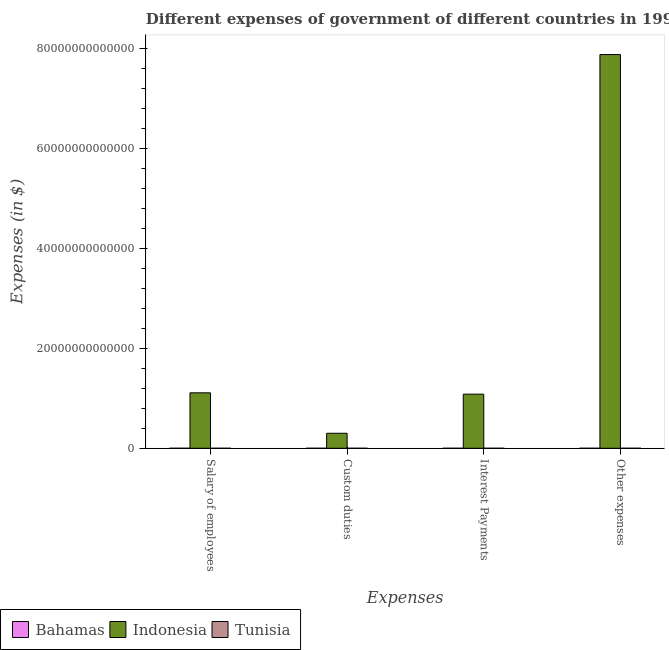How many different coloured bars are there?
Provide a succinct answer. 3. Are the number of bars per tick equal to the number of legend labels?
Keep it short and to the point. Yes. How many bars are there on the 1st tick from the left?
Ensure brevity in your answer.  3. What is the label of the 1st group of bars from the left?
Keep it short and to the point. Salary of employees. What is the amount spent on interest payments in Indonesia?
Make the answer very short. 1.08e+13. Across all countries, what is the maximum amount spent on other expenses?
Provide a short and direct response. 7.87e+13. Across all countries, what is the minimum amount spent on custom duties?
Provide a succinct answer. 3.46e+08. In which country was the amount spent on salary of employees minimum?
Your answer should be very brief. Bahamas. What is the total amount spent on salary of employees in the graph?
Make the answer very short. 1.11e+13. What is the difference between the amount spent on interest payments in Bahamas and that in Tunisia?
Give a very brief answer. -6.95e+08. What is the difference between the amount spent on custom duties in Indonesia and the amount spent on interest payments in Bahamas?
Keep it short and to the point. 3.00e+12. What is the average amount spent on other expenses per country?
Your response must be concise. 2.62e+13. What is the difference between the amount spent on interest payments and amount spent on custom duties in Indonesia?
Provide a short and direct response. 7.82e+12. In how many countries, is the amount spent on custom duties greater than 44000000000000 $?
Give a very brief answer. 0. What is the ratio of the amount spent on salary of employees in Indonesia to that in Bahamas?
Provide a succinct answer. 3.02e+04. Is the amount spent on other expenses in Bahamas less than that in Indonesia?
Ensure brevity in your answer.  Yes. Is the difference between the amount spent on salary of employees in Indonesia and Tunisia greater than the difference between the amount spent on interest payments in Indonesia and Tunisia?
Ensure brevity in your answer.  Yes. What is the difference between the highest and the second highest amount spent on salary of employees?
Provide a short and direct response. 1.11e+13. What is the difference between the highest and the lowest amount spent on other expenses?
Provide a succinct answer. 7.87e+13. Is the sum of the amount spent on custom duties in Bahamas and Tunisia greater than the maximum amount spent on other expenses across all countries?
Provide a short and direct response. No. Is it the case that in every country, the sum of the amount spent on other expenses and amount spent on salary of employees is greater than the sum of amount spent on interest payments and amount spent on custom duties?
Give a very brief answer. No. What does the 3rd bar from the left in Custom duties represents?
Your answer should be compact. Tunisia. How many bars are there?
Your answer should be very brief. 12. How many countries are there in the graph?
Ensure brevity in your answer.  3. What is the difference between two consecutive major ticks on the Y-axis?
Provide a short and direct response. 2.00e+13. Does the graph contain grids?
Give a very brief answer. No. What is the title of the graph?
Provide a succinct answer. Different expenses of government of different countries in 1997. What is the label or title of the X-axis?
Your answer should be compact. Expenses. What is the label or title of the Y-axis?
Make the answer very short. Expenses (in $). What is the Expenses (in $) of Bahamas in Salary of employees?
Make the answer very short. 3.67e+08. What is the Expenses (in $) of Indonesia in Salary of employees?
Provide a succinct answer. 1.11e+13. What is the Expenses (in $) of Tunisia in Salary of employees?
Your answer should be very brief. 2.32e+09. What is the Expenses (in $) of Bahamas in Custom duties?
Your answer should be very brief. 3.46e+08. What is the Expenses (in $) in Indonesia in Custom duties?
Your response must be concise. 3.00e+12. What is the Expenses (in $) of Tunisia in Custom duties?
Your answer should be compact. 8.49e+08. What is the Expenses (in $) in Bahamas in Interest Payments?
Give a very brief answer. 9.40e+07. What is the Expenses (in $) of Indonesia in Interest Payments?
Give a very brief answer. 1.08e+13. What is the Expenses (in $) in Tunisia in Interest Payments?
Offer a very short reply. 7.89e+08. What is the Expenses (in $) of Bahamas in Other expenses?
Provide a succinct answer. 7.12e+08. What is the Expenses (in $) of Indonesia in Other expenses?
Give a very brief answer. 7.87e+13. What is the Expenses (in $) of Tunisia in Other expenses?
Ensure brevity in your answer.  5.76e+09. Across all Expenses, what is the maximum Expenses (in $) of Bahamas?
Offer a terse response. 7.12e+08. Across all Expenses, what is the maximum Expenses (in $) of Indonesia?
Your response must be concise. 7.87e+13. Across all Expenses, what is the maximum Expenses (in $) in Tunisia?
Provide a short and direct response. 5.76e+09. Across all Expenses, what is the minimum Expenses (in $) of Bahamas?
Your answer should be compact. 9.40e+07. Across all Expenses, what is the minimum Expenses (in $) of Indonesia?
Your answer should be very brief. 3.00e+12. Across all Expenses, what is the minimum Expenses (in $) of Tunisia?
Provide a short and direct response. 7.89e+08. What is the total Expenses (in $) in Bahamas in the graph?
Your answer should be very brief. 1.52e+09. What is the total Expenses (in $) of Indonesia in the graph?
Your response must be concise. 1.04e+14. What is the total Expenses (in $) in Tunisia in the graph?
Provide a short and direct response. 9.72e+09. What is the difference between the Expenses (in $) in Bahamas in Salary of employees and that in Custom duties?
Your answer should be very brief. 2.14e+07. What is the difference between the Expenses (in $) of Indonesia in Salary of employees and that in Custom duties?
Provide a short and direct response. 8.09e+12. What is the difference between the Expenses (in $) of Tunisia in Salary of employees and that in Custom duties?
Give a very brief answer. 1.47e+09. What is the difference between the Expenses (in $) of Bahamas in Salary of employees and that in Interest Payments?
Provide a succinct answer. 2.73e+08. What is the difference between the Expenses (in $) of Indonesia in Salary of employees and that in Interest Payments?
Provide a short and direct response. 2.68e+11. What is the difference between the Expenses (in $) of Tunisia in Salary of employees and that in Interest Payments?
Ensure brevity in your answer.  1.53e+09. What is the difference between the Expenses (in $) in Bahamas in Salary of employees and that in Other expenses?
Provide a succinct answer. -3.45e+08. What is the difference between the Expenses (in $) of Indonesia in Salary of employees and that in Other expenses?
Give a very brief answer. -6.76e+13. What is the difference between the Expenses (in $) of Tunisia in Salary of employees and that in Other expenses?
Ensure brevity in your answer.  -3.44e+09. What is the difference between the Expenses (in $) in Bahamas in Custom duties and that in Interest Payments?
Your response must be concise. 2.52e+08. What is the difference between the Expenses (in $) of Indonesia in Custom duties and that in Interest Payments?
Keep it short and to the point. -7.82e+12. What is the difference between the Expenses (in $) in Tunisia in Custom duties and that in Interest Payments?
Your answer should be very brief. 5.99e+07. What is the difference between the Expenses (in $) in Bahamas in Custom duties and that in Other expenses?
Make the answer very short. -3.66e+08. What is the difference between the Expenses (in $) in Indonesia in Custom duties and that in Other expenses?
Your answer should be very brief. -7.57e+13. What is the difference between the Expenses (in $) in Tunisia in Custom duties and that in Other expenses?
Your answer should be very brief. -4.92e+09. What is the difference between the Expenses (in $) in Bahamas in Interest Payments and that in Other expenses?
Keep it short and to the point. -6.18e+08. What is the difference between the Expenses (in $) in Indonesia in Interest Payments and that in Other expenses?
Provide a short and direct response. -6.79e+13. What is the difference between the Expenses (in $) of Tunisia in Interest Payments and that in Other expenses?
Keep it short and to the point. -4.98e+09. What is the difference between the Expenses (in $) in Bahamas in Salary of employees and the Expenses (in $) in Indonesia in Custom duties?
Provide a succinct answer. -3.00e+12. What is the difference between the Expenses (in $) of Bahamas in Salary of employees and the Expenses (in $) of Tunisia in Custom duties?
Your answer should be very brief. -4.82e+08. What is the difference between the Expenses (in $) in Indonesia in Salary of employees and the Expenses (in $) in Tunisia in Custom duties?
Make the answer very short. 1.11e+13. What is the difference between the Expenses (in $) in Bahamas in Salary of employees and the Expenses (in $) in Indonesia in Interest Payments?
Provide a short and direct response. -1.08e+13. What is the difference between the Expenses (in $) in Bahamas in Salary of employees and the Expenses (in $) in Tunisia in Interest Payments?
Offer a very short reply. -4.22e+08. What is the difference between the Expenses (in $) in Indonesia in Salary of employees and the Expenses (in $) in Tunisia in Interest Payments?
Keep it short and to the point. 1.11e+13. What is the difference between the Expenses (in $) in Bahamas in Salary of employees and the Expenses (in $) in Indonesia in Other expenses?
Your response must be concise. -7.87e+13. What is the difference between the Expenses (in $) of Bahamas in Salary of employees and the Expenses (in $) of Tunisia in Other expenses?
Provide a succinct answer. -5.40e+09. What is the difference between the Expenses (in $) of Indonesia in Salary of employees and the Expenses (in $) of Tunisia in Other expenses?
Provide a succinct answer. 1.11e+13. What is the difference between the Expenses (in $) in Bahamas in Custom duties and the Expenses (in $) in Indonesia in Interest Payments?
Your response must be concise. -1.08e+13. What is the difference between the Expenses (in $) in Bahamas in Custom duties and the Expenses (in $) in Tunisia in Interest Payments?
Provide a short and direct response. -4.43e+08. What is the difference between the Expenses (in $) of Indonesia in Custom duties and the Expenses (in $) of Tunisia in Interest Payments?
Your answer should be very brief. 3.00e+12. What is the difference between the Expenses (in $) of Bahamas in Custom duties and the Expenses (in $) of Indonesia in Other expenses?
Offer a very short reply. -7.87e+13. What is the difference between the Expenses (in $) in Bahamas in Custom duties and the Expenses (in $) in Tunisia in Other expenses?
Provide a short and direct response. -5.42e+09. What is the difference between the Expenses (in $) in Indonesia in Custom duties and the Expenses (in $) in Tunisia in Other expenses?
Your answer should be compact. 2.99e+12. What is the difference between the Expenses (in $) in Bahamas in Interest Payments and the Expenses (in $) in Indonesia in Other expenses?
Offer a terse response. -7.87e+13. What is the difference between the Expenses (in $) in Bahamas in Interest Payments and the Expenses (in $) in Tunisia in Other expenses?
Your answer should be compact. -5.67e+09. What is the difference between the Expenses (in $) of Indonesia in Interest Payments and the Expenses (in $) of Tunisia in Other expenses?
Ensure brevity in your answer.  1.08e+13. What is the average Expenses (in $) of Bahamas per Expenses?
Keep it short and to the point. 3.80e+08. What is the average Expenses (in $) of Indonesia per Expenses?
Ensure brevity in your answer.  2.59e+13. What is the average Expenses (in $) of Tunisia per Expenses?
Ensure brevity in your answer.  2.43e+09. What is the difference between the Expenses (in $) in Bahamas and Expenses (in $) in Indonesia in Salary of employees?
Give a very brief answer. -1.11e+13. What is the difference between the Expenses (in $) of Bahamas and Expenses (in $) of Tunisia in Salary of employees?
Your answer should be compact. -1.95e+09. What is the difference between the Expenses (in $) of Indonesia and Expenses (in $) of Tunisia in Salary of employees?
Provide a short and direct response. 1.11e+13. What is the difference between the Expenses (in $) of Bahamas and Expenses (in $) of Indonesia in Custom duties?
Make the answer very short. -3.00e+12. What is the difference between the Expenses (in $) in Bahamas and Expenses (in $) in Tunisia in Custom duties?
Your answer should be very brief. -5.03e+08. What is the difference between the Expenses (in $) in Indonesia and Expenses (in $) in Tunisia in Custom duties?
Give a very brief answer. 3.00e+12. What is the difference between the Expenses (in $) of Bahamas and Expenses (in $) of Indonesia in Interest Payments?
Make the answer very short. -1.08e+13. What is the difference between the Expenses (in $) of Bahamas and Expenses (in $) of Tunisia in Interest Payments?
Keep it short and to the point. -6.95e+08. What is the difference between the Expenses (in $) in Indonesia and Expenses (in $) in Tunisia in Interest Payments?
Provide a short and direct response. 1.08e+13. What is the difference between the Expenses (in $) in Bahamas and Expenses (in $) in Indonesia in Other expenses?
Make the answer very short. -7.87e+13. What is the difference between the Expenses (in $) in Bahamas and Expenses (in $) in Tunisia in Other expenses?
Your response must be concise. -5.05e+09. What is the difference between the Expenses (in $) in Indonesia and Expenses (in $) in Tunisia in Other expenses?
Your answer should be very brief. 7.87e+13. What is the ratio of the Expenses (in $) in Bahamas in Salary of employees to that in Custom duties?
Ensure brevity in your answer.  1.06. What is the ratio of the Expenses (in $) in Indonesia in Salary of employees to that in Custom duties?
Your answer should be very brief. 3.7. What is the ratio of the Expenses (in $) in Tunisia in Salary of employees to that in Custom duties?
Your answer should be compact. 2.73. What is the ratio of the Expenses (in $) of Bahamas in Salary of employees to that in Interest Payments?
Your answer should be compact. 3.9. What is the ratio of the Expenses (in $) in Indonesia in Salary of employees to that in Interest Payments?
Give a very brief answer. 1.02. What is the ratio of the Expenses (in $) in Tunisia in Salary of employees to that in Interest Payments?
Provide a succinct answer. 2.94. What is the ratio of the Expenses (in $) in Bahamas in Salary of employees to that in Other expenses?
Offer a terse response. 0.52. What is the ratio of the Expenses (in $) in Indonesia in Salary of employees to that in Other expenses?
Offer a terse response. 0.14. What is the ratio of the Expenses (in $) in Tunisia in Salary of employees to that in Other expenses?
Your answer should be very brief. 0.4. What is the ratio of the Expenses (in $) of Bahamas in Custom duties to that in Interest Payments?
Your response must be concise. 3.68. What is the ratio of the Expenses (in $) in Indonesia in Custom duties to that in Interest Payments?
Your response must be concise. 0.28. What is the ratio of the Expenses (in $) of Tunisia in Custom duties to that in Interest Payments?
Offer a very short reply. 1.08. What is the ratio of the Expenses (in $) in Bahamas in Custom duties to that in Other expenses?
Make the answer very short. 0.49. What is the ratio of the Expenses (in $) of Indonesia in Custom duties to that in Other expenses?
Ensure brevity in your answer.  0.04. What is the ratio of the Expenses (in $) in Tunisia in Custom duties to that in Other expenses?
Offer a very short reply. 0.15. What is the ratio of the Expenses (in $) in Bahamas in Interest Payments to that in Other expenses?
Make the answer very short. 0.13. What is the ratio of the Expenses (in $) of Indonesia in Interest Payments to that in Other expenses?
Your response must be concise. 0.14. What is the ratio of the Expenses (in $) in Tunisia in Interest Payments to that in Other expenses?
Your answer should be very brief. 0.14. What is the difference between the highest and the second highest Expenses (in $) of Bahamas?
Offer a very short reply. 3.45e+08. What is the difference between the highest and the second highest Expenses (in $) of Indonesia?
Ensure brevity in your answer.  6.76e+13. What is the difference between the highest and the second highest Expenses (in $) of Tunisia?
Provide a succinct answer. 3.44e+09. What is the difference between the highest and the lowest Expenses (in $) of Bahamas?
Give a very brief answer. 6.18e+08. What is the difference between the highest and the lowest Expenses (in $) in Indonesia?
Your response must be concise. 7.57e+13. What is the difference between the highest and the lowest Expenses (in $) in Tunisia?
Give a very brief answer. 4.98e+09. 